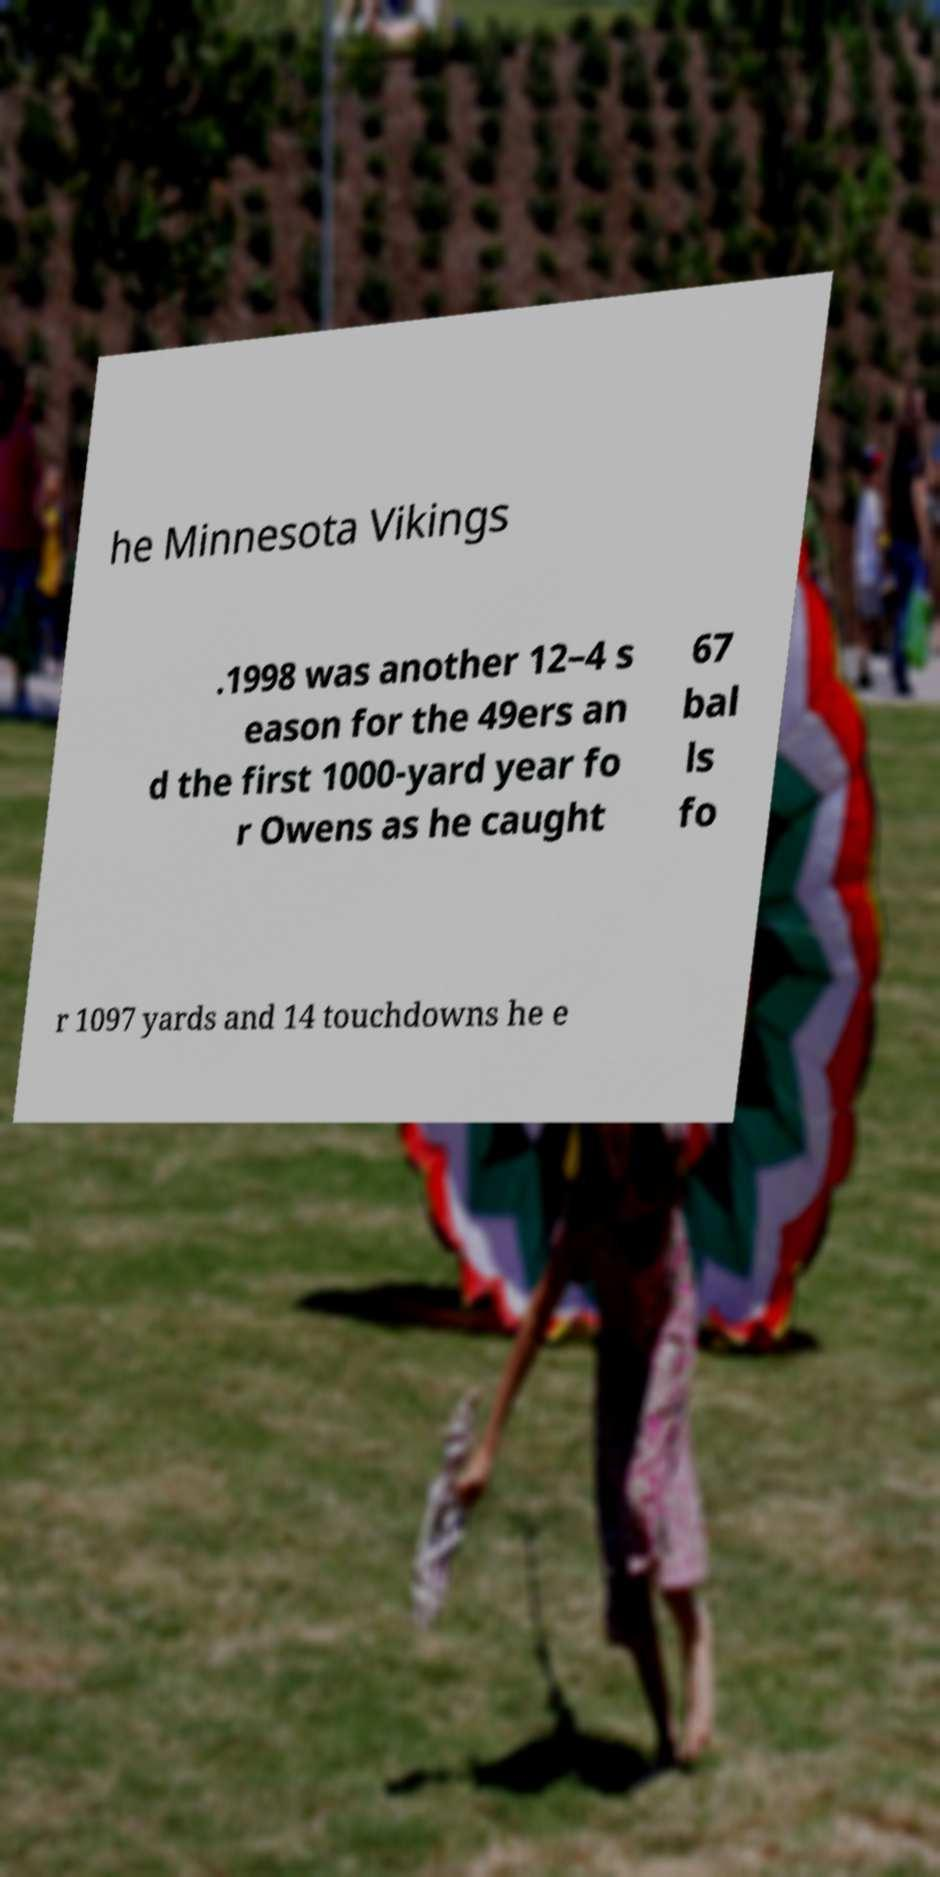Can you read and provide the text displayed in the image?This photo seems to have some interesting text. Can you extract and type it out for me? he Minnesota Vikings .1998 was another 12–4 s eason for the 49ers an d the first 1000-yard year fo r Owens as he caught 67 bal ls fo r 1097 yards and 14 touchdowns he e 